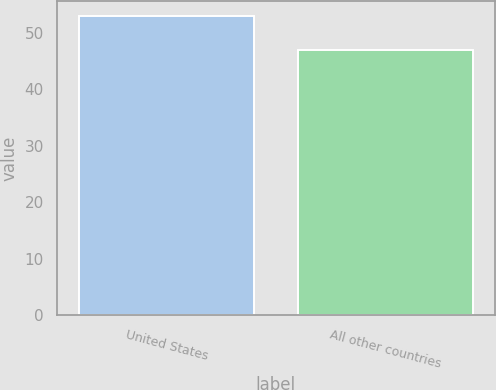<chart> <loc_0><loc_0><loc_500><loc_500><bar_chart><fcel>United States<fcel>All other countries<nl><fcel>53<fcel>47<nl></chart> 